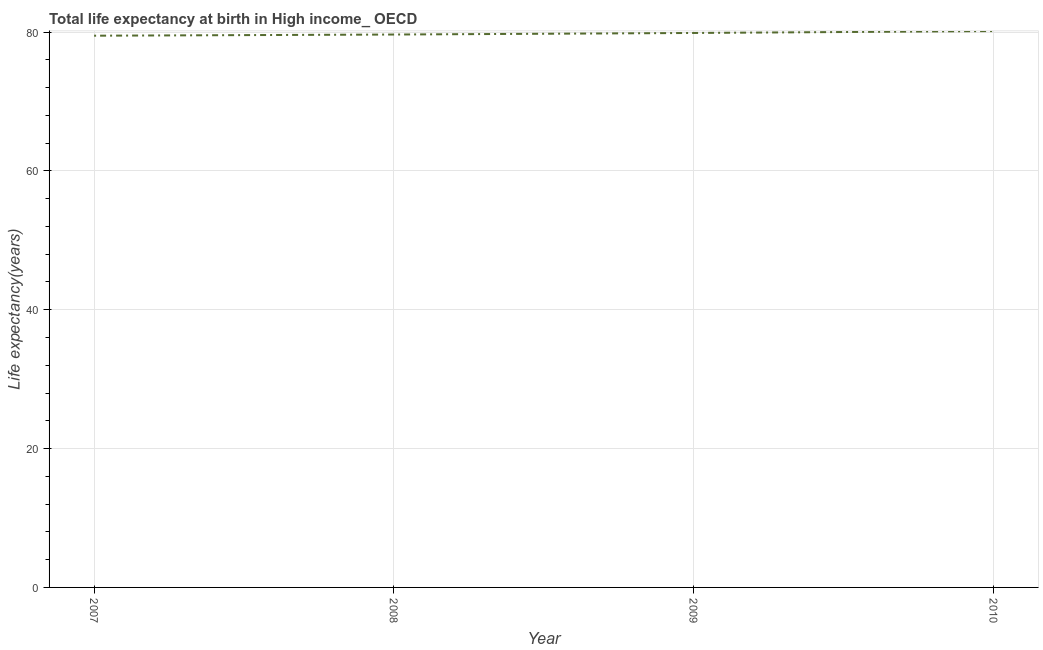What is the life expectancy at birth in 2009?
Keep it short and to the point. 79.86. Across all years, what is the maximum life expectancy at birth?
Provide a succinct answer. 80.14. Across all years, what is the minimum life expectancy at birth?
Ensure brevity in your answer.  79.47. In which year was the life expectancy at birth minimum?
Your answer should be very brief. 2007. What is the sum of the life expectancy at birth?
Give a very brief answer. 319.1. What is the difference between the life expectancy at birth in 2007 and 2009?
Provide a succinct answer. -0.39. What is the average life expectancy at birth per year?
Ensure brevity in your answer.  79.78. What is the median life expectancy at birth?
Your answer should be compact. 79.75. In how many years, is the life expectancy at birth greater than 72 years?
Make the answer very short. 4. Do a majority of the years between 2009 and 2007 (inclusive) have life expectancy at birth greater than 68 years?
Offer a terse response. No. What is the ratio of the life expectancy at birth in 2008 to that in 2010?
Offer a terse response. 0.99. What is the difference between the highest and the second highest life expectancy at birth?
Give a very brief answer. 0.28. What is the difference between the highest and the lowest life expectancy at birth?
Provide a short and direct response. 0.67. What is the difference between two consecutive major ticks on the Y-axis?
Make the answer very short. 20. Does the graph contain any zero values?
Give a very brief answer. No. Does the graph contain grids?
Keep it short and to the point. Yes. What is the title of the graph?
Your response must be concise. Total life expectancy at birth in High income_ OECD. What is the label or title of the X-axis?
Your answer should be very brief. Year. What is the label or title of the Y-axis?
Your answer should be compact. Life expectancy(years). What is the Life expectancy(years) of 2007?
Keep it short and to the point. 79.47. What is the Life expectancy(years) in 2008?
Make the answer very short. 79.64. What is the Life expectancy(years) in 2009?
Your answer should be compact. 79.86. What is the Life expectancy(years) of 2010?
Keep it short and to the point. 80.14. What is the difference between the Life expectancy(years) in 2007 and 2008?
Provide a succinct answer. -0.17. What is the difference between the Life expectancy(years) in 2007 and 2009?
Your answer should be very brief. -0.39. What is the difference between the Life expectancy(years) in 2007 and 2010?
Your answer should be compact. -0.67. What is the difference between the Life expectancy(years) in 2008 and 2009?
Make the answer very short. -0.22. What is the difference between the Life expectancy(years) in 2008 and 2010?
Make the answer very short. -0.5. What is the difference between the Life expectancy(years) in 2009 and 2010?
Offer a very short reply. -0.28. What is the ratio of the Life expectancy(years) in 2008 to that in 2010?
Your answer should be compact. 0.99. 